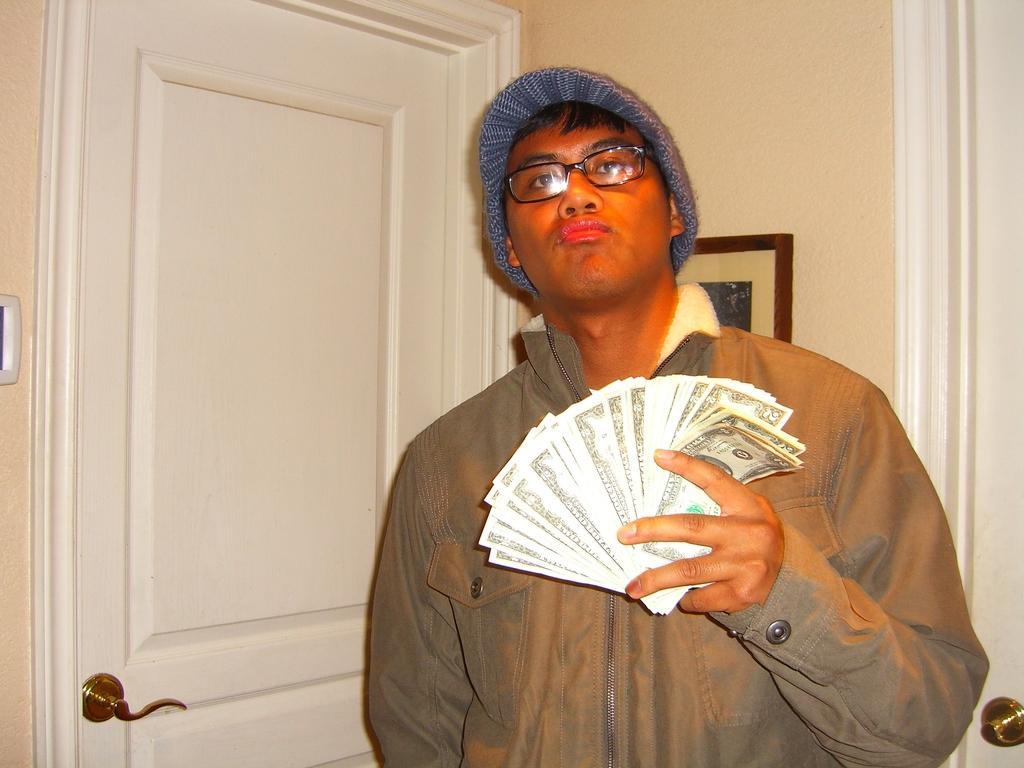Can you describe this image briefly? In the image there is a man with a hat on his and he kept spectacles. And he is holding the currency notes in his hands. Behind him there is a wall with frame. And also there are white colored doors on the wall. 